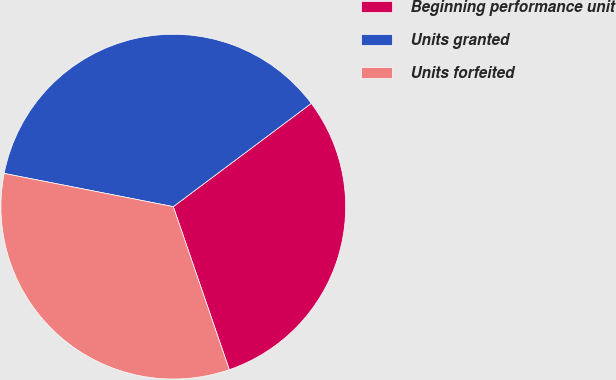Convert chart to OTSL. <chart><loc_0><loc_0><loc_500><loc_500><pie_chart><fcel>Beginning performance unit<fcel>Units granted<fcel>Units forfeited<nl><fcel>29.96%<fcel>36.69%<fcel>33.35%<nl></chart> 